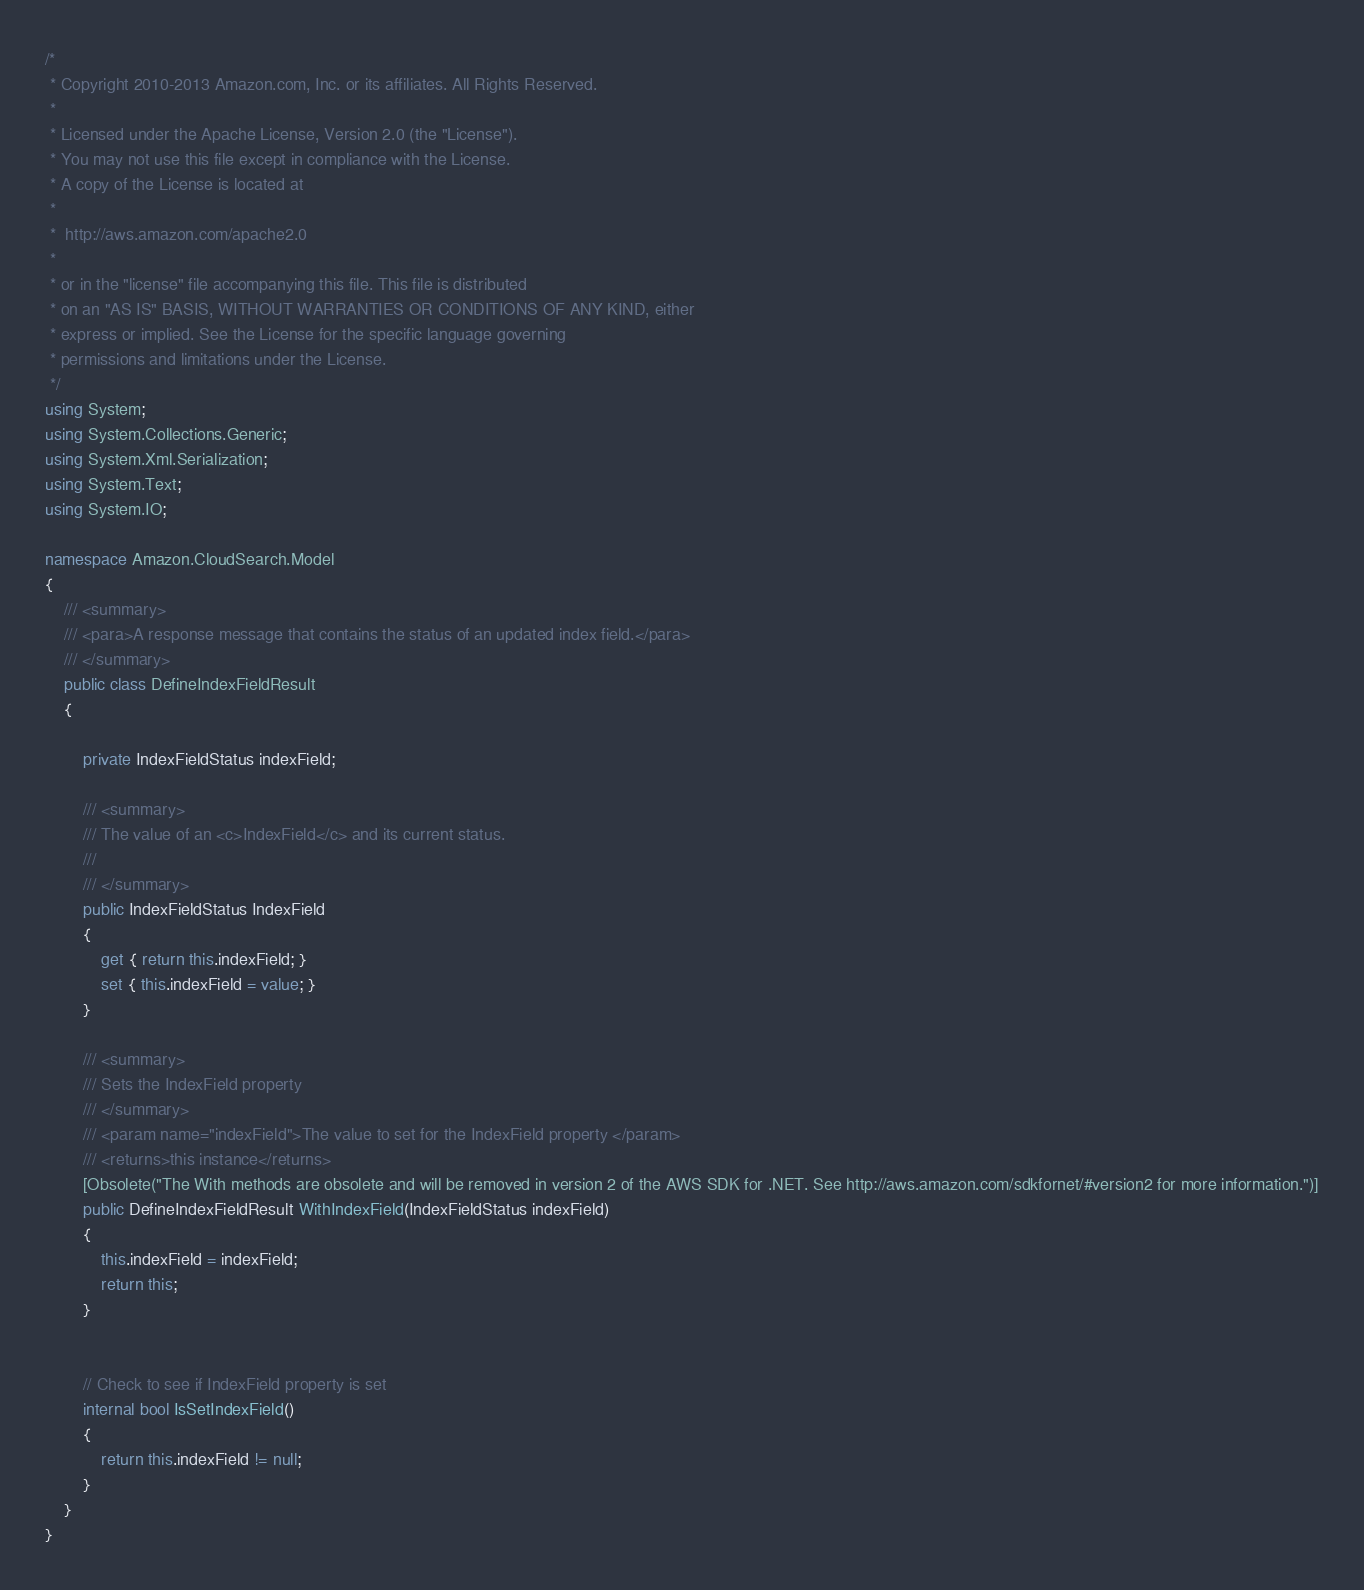<code> <loc_0><loc_0><loc_500><loc_500><_C#_>/*
 * Copyright 2010-2013 Amazon.com, Inc. or its affiliates. All Rights Reserved.
 * 
 * Licensed under the Apache License, Version 2.0 (the "License").
 * You may not use this file except in compliance with the License.
 * A copy of the License is located at
 * 
 *  http://aws.amazon.com/apache2.0
 * 
 * or in the "license" file accompanying this file. This file is distributed
 * on an "AS IS" BASIS, WITHOUT WARRANTIES OR CONDITIONS OF ANY KIND, either
 * express or implied. See the License for the specific language governing
 * permissions and limitations under the License.
 */
using System;
using System.Collections.Generic;
using System.Xml.Serialization;
using System.Text;
using System.IO;

namespace Amazon.CloudSearch.Model
{
    /// <summary>
    /// <para>A response message that contains the status of an updated index field.</para>
    /// </summary>
    public class DefineIndexFieldResult  
    {
        
        private IndexFieldStatus indexField;

        /// <summary>
        /// The value of an <c>IndexField</c> and its current status.
        ///  
        /// </summary>
        public IndexFieldStatus IndexField
        {
            get { return this.indexField; }
            set { this.indexField = value; }
        }

        /// <summary>
        /// Sets the IndexField property
        /// </summary>
        /// <param name="indexField">The value to set for the IndexField property </param>
        /// <returns>this instance</returns>
        [Obsolete("The With methods are obsolete and will be removed in version 2 of the AWS SDK for .NET. See http://aws.amazon.com/sdkfornet/#version2 for more information.")]
        public DefineIndexFieldResult WithIndexField(IndexFieldStatus indexField)
        {
            this.indexField = indexField;
            return this;
        }
            

        // Check to see if IndexField property is set
        internal bool IsSetIndexField()
        {
            return this.indexField != null;       
        }
    }
}
</code> 